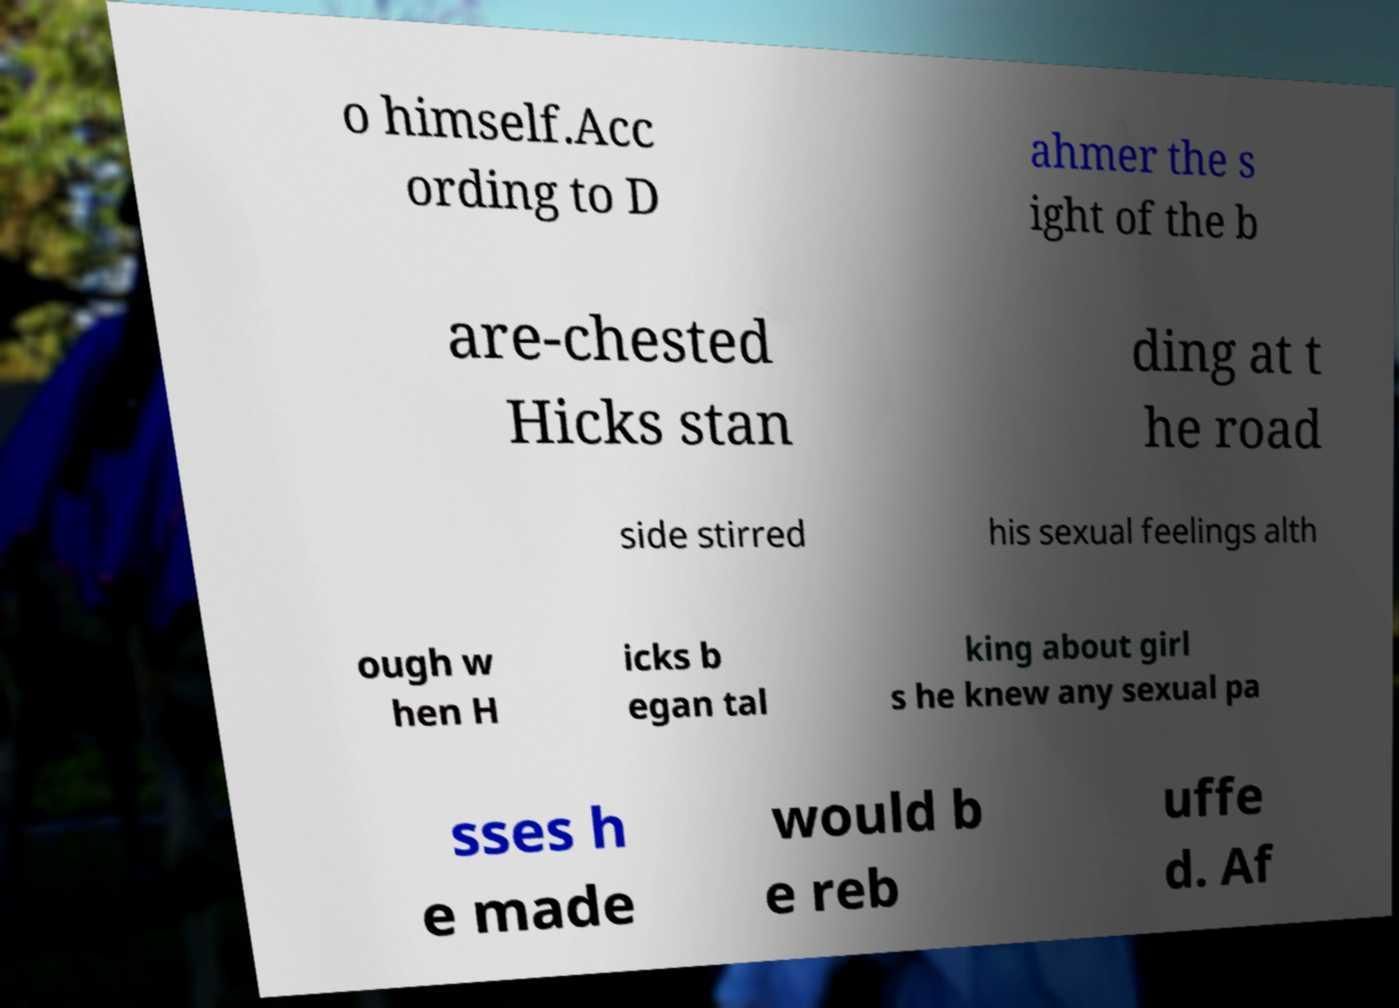Please identify and transcribe the text found in this image. o himself.Acc ording to D ahmer the s ight of the b are-chested Hicks stan ding at t he road side stirred his sexual feelings alth ough w hen H icks b egan tal king about girl s he knew any sexual pa sses h e made would b e reb uffe d. Af 